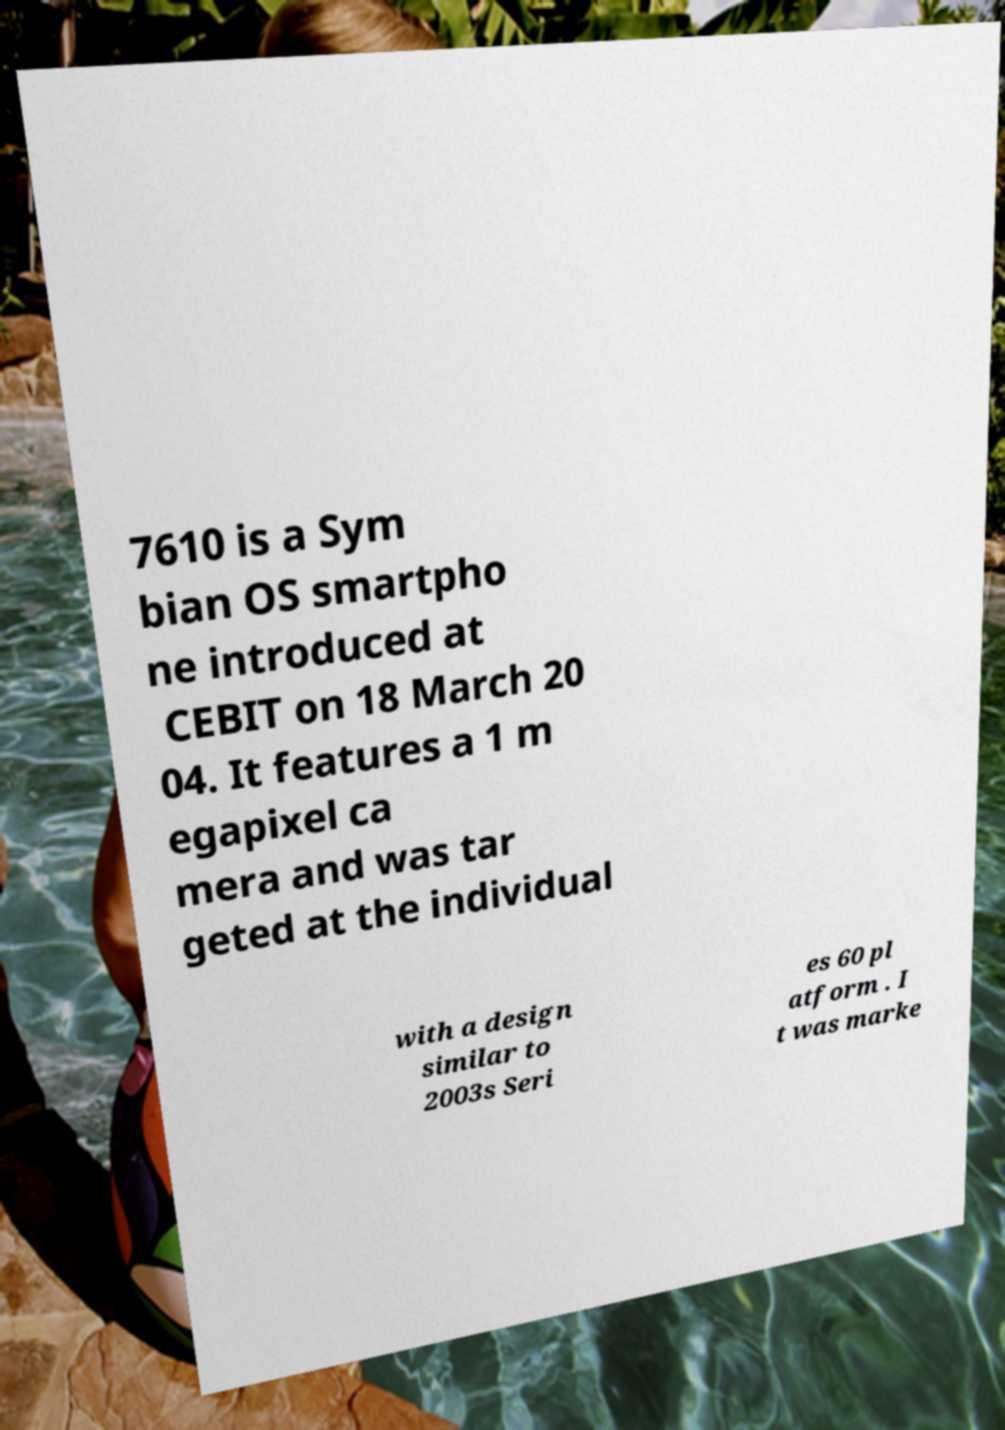Can you read and provide the text displayed in the image?This photo seems to have some interesting text. Can you extract and type it out for me? 7610 is a Sym bian OS smartpho ne introduced at CEBIT on 18 March 20 04. It features a 1 m egapixel ca mera and was tar geted at the individual with a design similar to 2003s Seri es 60 pl atform . I t was marke 